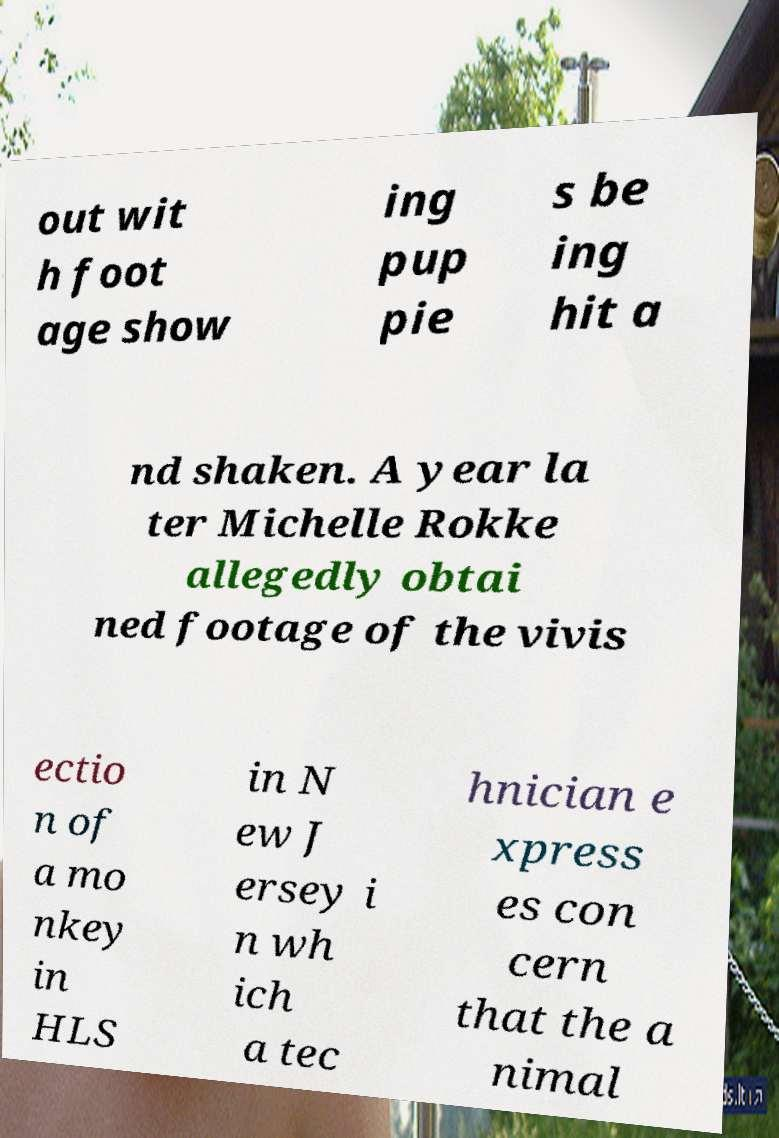Can you read and provide the text displayed in the image?This photo seems to have some interesting text. Can you extract and type it out for me? out wit h foot age show ing pup pie s be ing hit a nd shaken. A year la ter Michelle Rokke allegedly obtai ned footage of the vivis ectio n of a mo nkey in HLS in N ew J ersey i n wh ich a tec hnician e xpress es con cern that the a nimal 